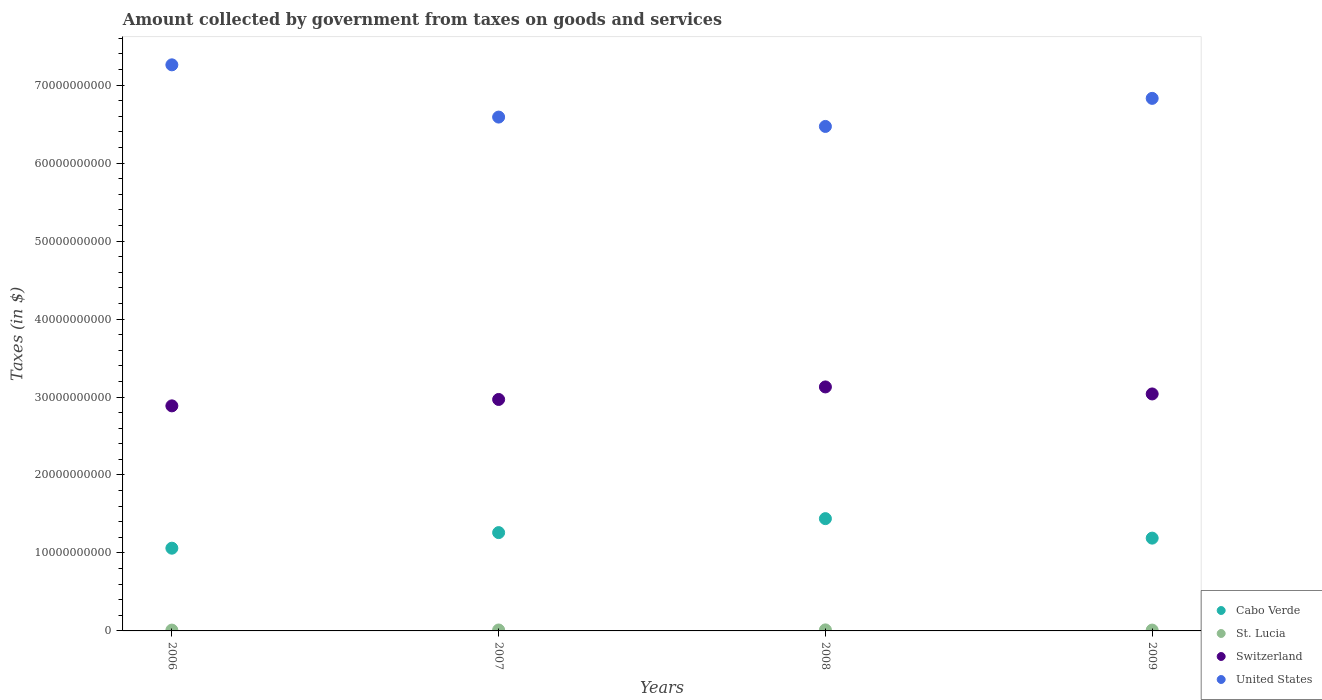How many different coloured dotlines are there?
Your answer should be compact. 4. What is the amount collected by government from taxes on goods and services in United States in 2006?
Your answer should be very brief. 7.26e+1. Across all years, what is the maximum amount collected by government from taxes on goods and services in United States?
Make the answer very short. 7.26e+1. Across all years, what is the minimum amount collected by government from taxes on goods and services in United States?
Offer a terse response. 6.47e+1. In which year was the amount collected by government from taxes on goods and services in Cabo Verde maximum?
Your response must be concise. 2008. What is the total amount collected by government from taxes on goods and services in St. Lucia in the graph?
Give a very brief answer. 4.65e+08. What is the difference between the amount collected by government from taxes on goods and services in Cabo Verde in 2006 and that in 2009?
Provide a short and direct response. -1.29e+09. What is the difference between the amount collected by government from taxes on goods and services in United States in 2006 and the amount collected by government from taxes on goods and services in Switzerland in 2009?
Offer a terse response. 4.22e+1. What is the average amount collected by government from taxes on goods and services in Switzerland per year?
Ensure brevity in your answer.  3.01e+1. In the year 2008, what is the difference between the amount collected by government from taxes on goods and services in United States and amount collected by government from taxes on goods and services in Cabo Verde?
Give a very brief answer. 5.03e+1. In how many years, is the amount collected by government from taxes on goods and services in Switzerland greater than 62000000000 $?
Provide a short and direct response. 0. What is the ratio of the amount collected by government from taxes on goods and services in Switzerland in 2008 to that in 2009?
Your answer should be very brief. 1.03. Is the amount collected by government from taxes on goods and services in United States in 2006 less than that in 2008?
Provide a succinct answer. No. What is the difference between the highest and the second highest amount collected by government from taxes on goods and services in Cabo Verde?
Offer a very short reply. 1.79e+09. What is the difference between the highest and the lowest amount collected by government from taxes on goods and services in United States?
Offer a very short reply. 7.90e+09. Is the sum of the amount collected by government from taxes on goods and services in United States in 2006 and 2009 greater than the maximum amount collected by government from taxes on goods and services in Cabo Verde across all years?
Your answer should be very brief. Yes. Is it the case that in every year, the sum of the amount collected by government from taxes on goods and services in Cabo Verde and amount collected by government from taxes on goods and services in United States  is greater than the sum of amount collected by government from taxes on goods and services in St. Lucia and amount collected by government from taxes on goods and services in Switzerland?
Offer a very short reply. Yes. Is it the case that in every year, the sum of the amount collected by government from taxes on goods and services in Cabo Verde and amount collected by government from taxes on goods and services in United States  is greater than the amount collected by government from taxes on goods and services in Switzerland?
Make the answer very short. Yes. Does the amount collected by government from taxes on goods and services in Switzerland monotonically increase over the years?
Provide a succinct answer. No. Is the amount collected by government from taxes on goods and services in Switzerland strictly greater than the amount collected by government from taxes on goods and services in United States over the years?
Make the answer very short. No. How many dotlines are there?
Offer a terse response. 4. How many years are there in the graph?
Keep it short and to the point. 4. What is the difference between two consecutive major ticks on the Y-axis?
Your response must be concise. 1.00e+1. Are the values on the major ticks of Y-axis written in scientific E-notation?
Provide a succinct answer. No. Where does the legend appear in the graph?
Provide a succinct answer. Bottom right. How are the legend labels stacked?
Offer a terse response. Vertical. What is the title of the graph?
Ensure brevity in your answer.  Amount collected by government from taxes on goods and services. Does "French Polynesia" appear as one of the legend labels in the graph?
Your response must be concise. No. What is the label or title of the Y-axis?
Offer a terse response. Taxes (in $). What is the Taxes (in $) in Cabo Verde in 2006?
Offer a terse response. 1.06e+1. What is the Taxes (in $) in St. Lucia in 2006?
Make the answer very short. 1.06e+08. What is the Taxes (in $) of Switzerland in 2006?
Your response must be concise. 2.89e+1. What is the Taxes (in $) of United States in 2006?
Give a very brief answer. 7.26e+1. What is the Taxes (in $) in Cabo Verde in 2007?
Ensure brevity in your answer.  1.26e+1. What is the Taxes (in $) of St. Lucia in 2007?
Provide a succinct answer. 1.20e+08. What is the Taxes (in $) in Switzerland in 2007?
Your answer should be very brief. 2.97e+1. What is the Taxes (in $) in United States in 2007?
Ensure brevity in your answer.  6.59e+1. What is the Taxes (in $) in Cabo Verde in 2008?
Make the answer very short. 1.44e+1. What is the Taxes (in $) of St. Lucia in 2008?
Offer a very short reply. 1.32e+08. What is the Taxes (in $) in Switzerland in 2008?
Make the answer very short. 3.13e+1. What is the Taxes (in $) in United States in 2008?
Make the answer very short. 6.47e+1. What is the Taxes (in $) in Cabo Verde in 2009?
Keep it short and to the point. 1.19e+1. What is the Taxes (in $) in St. Lucia in 2009?
Make the answer very short. 1.07e+08. What is the Taxes (in $) in Switzerland in 2009?
Your answer should be compact. 3.04e+1. What is the Taxes (in $) in United States in 2009?
Provide a succinct answer. 6.83e+1. Across all years, what is the maximum Taxes (in $) of Cabo Verde?
Provide a short and direct response. 1.44e+1. Across all years, what is the maximum Taxes (in $) in St. Lucia?
Make the answer very short. 1.32e+08. Across all years, what is the maximum Taxes (in $) in Switzerland?
Your response must be concise. 3.13e+1. Across all years, what is the maximum Taxes (in $) in United States?
Offer a very short reply. 7.26e+1. Across all years, what is the minimum Taxes (in $) in Cabo Verde?
Offer a terse response. 1.06e+1. Across all years, what is the minimum Taxes (in $) of St. Lucia?
Your answer should be compact. 1.06e+08. Across all years, what is the minimum Taxes (in $) in Switzerland?
Provide a short and direct response. 2.89e+1. Across all years, what is the minimum Taxes (in $) in United States?
Give a very brief answer. 6.47e+1. What is the total Taxes (in $) of Cabo Verde in the graph?
Provide a succinct answer. 4.95e+1. What is the total Taxes (in $) of St. Lucia in the graph?
Ensure brevity in your answer.  4.65e+08. What is the total Taxes (in $) in Switzerland in the graph?
Make the answer very short. 1.20e+11. What is the total Taxes (in $) in United States in the graph?
Your answer should be compact. 2.72e+11. What is the difference between the Taxes (in $) of Cabo Verde in 2006 and that in 2007?
Make the answer very short. -2.00e+09. What is the difference between the Taxes (in $) of St. Lucia in 2006 and that in 2007?
Offer a very short reply. -1.41e+07. What is the difference between the Taxes (in $) of Switzerland in 2006 and that in 2007?
Give a very brief answer. -8.22e+08. What is the difference between the Taxes (in $) of United States in 2006 and that in 2007?
Make the answer very short. 6.70e+09. What is the difference between the Taxes (in $) in Cabo Verde in 2006 and that in 2008?
Make the answer very short. -3.79e+09. What is the difference between the Taxes (in $) in St. Lucia in 2006 and that in 2008?
Provide a succinct answer. -2.66e+07. What is the difference between the Taxes (in $) in Switzerland in 2006 and that in 2008?
Provide a short and direct response. -2.43e+09. What is the difference between the Taxes (in $) in United States in 2006 and that in 2008?
Make the answer very short. 7.90e+09. What is the difference between the Taxes (in $) of Cabo Verde in 2006 and that in 2009?
Provide a short and direct response. -1.29e+09. What is the difference between the Taxes (in $) of St. Lucia in 2006 and that in 2009?
Offer a very short reply. -1.80e+06. What is the difference between the Taxes (in $) of Switzerland in 2006 and that in 2009?
Give a very brief answer. -1.53e+09. What is the difference between the Taxes (in $) in United States in 2006 and that in 2009?
Your answer should be very brief. 4.30e+09. What is the difference between the Taxes (in $) in Cabo Verde in 2007 and that in 2008?
Make the answer very short. -1.79e+09. What is the difference between the Taxes (in $) in St. Lucia in 2007 and that in 2008?
Keep it short and to the point. -1.25e+07. What is the difference between the Taxes (in $) of Switzerland in 2007 and that in 2008?
Offer a very short reply. -1.61e+09. What is the difference between the Taxes (in $) in United States in 2007 and that in 2008?
Offer a very short reply. 1.20e+09. What is the difference between the Taxes (in $) in Cabo Verde in 2007 and that in 2009?
Your response must be concise. 7.08e+08. What is the difference between the Taxes (in $) in St. Lucia in 2007 and that in 2009?
Keep it short and to the point. 1.23e+07. What is the difference between the Taxes (in $) of Switzerland in 2007 and that in 2009?
Make the answer very short. -7.08e+08. What is the difference between the Taxes (in $) in United States in 2007 and that in 2009?
Make the answer very short. -2.40e+09. What is the difference between the Taxes (in $) in Cabo Verde in 2008 and that in 2009?
Provide a succinct answer. 2.50e+09. What is the difference between the Taxes (in $) in St. Lucia in 2008 and that in 2009?
Your answer should be very brief. 2.48e+07. What is the difference between the Taxes (in $) in Switzerland in 2008 and that in 2009?
Your answer should be very brief. 9.00e+08. What is the difference between the Taxes (in $) in United States in 2008 and that in 2009?
Your response must be concise. -3.60e+09. What is the difference between the Taxes (in $) in Cabo Verde in 2006 and the Taxes (in $) in St. Lucia in 2007?
Provide a succinct answer. 1.05e+1. What is the difference between the Taxes (in $) in Cabo Verde in 2006 and the Taxes (in $) in Switzerland in 2007?
Offer a terse response. -1.91e+1. What is the difference between the Taxes (in $) in Cabo Verde in 2006 and the Taxes (in $) in United States in 2007?
Your response must be concise. -5.53e+1. What is the difference between the Taxes (in $) of St. Lucia in 2006 and the Taxes (in $) of Switzerland in 2007?
Make the answer very short. -2.96e+1. What is the difference between the Taxes (in $) of St. Lucia in 2006 and the Taxes (in $) of United States in 2007?
Provide a succinct answer. -6.58e+1. What is the difference between the Taxes (in $) in Switzerland in 2006 and the Taxes (in $) in United States in 2007?
Make the answer very short. -3.70e+1. What is the difference between the Taxes (in $) in Cabo Verde in 2006 and the Taxes (in $) in St. Lucia in 2008?
Ensure brevity in your answer.  1.05e+1. What is the difference between the Taxes (in $) in Cabo Verde in 2006 and the Taxes (in $) in Switzerland in 2008?
Your response must be concise. -2.07e+1. What is the difference between the Taxes (in $) in Cabo Verde in 2006 and the Taxes (in $) in United States in 2008?
Keep it short and to the point. -5.41e+1. What is the difference between the Taxes (in $) in St. Lucia in 2006 and the Taxes (in $) in Switzerland in 2008?
Keep it short and to the point. -3.12e+1. What is the difference between the Taxes (in $) in St. Lucia in 2006 and the Taxes (in $) in United States in 2008?
Provide a short and direct response. -6.46e+1. What is the difference between the Taxes (in $) in Switzerland in 2006 and the Taxes (in $) in United States in 2008?
Your response must be concise. -3.58e+1. What is the difference between the Taxes (in $) of Cabo Verde in 2006 and the Taxes (in $) of St. Lucia in 2009?
Your response must be concise. 1.05e+1. What is the difference between the Taxes (in $) in Cabo Verde in 2006 and the Taxes (in $) in Switzerland in 2009?
Keep it short and to the point. -1.98e+1. What is the difference between the Taxes (in $) in Cabo Verde in 2006 and the Taxes (in $) in United States in 2009?
Your response must be concise. -5.77e+1. What is the difference between the Taxes (in $) of St. Lucia in 2006 and the Taxes (in $) of Switzerland in 2009?
Offer a very short reply. -3.03e+1. What is the difference between the Taxes (in $) of St. Lucia in 2006 and the Taxes (in $) of United States in 2009?
Provide a short and direct response. -6.82e+1. What is the difference between the Taxes (in $) in Switzerland in 2006 and the Taxes (in $) in United States in 2009?
Provide a short and direct response. -3.94e+1. What is the difference between the Taxes (in $) of Cabo Verde in 2007 and the Taxes (in $) of St. Lucia in 2008?
Provide a succinct answer. 1.25e+1. What is the difference between the Taxes (in $) in Cabo Verde in 2007 and the Taxes (in $) in Switzerland in 2008?
Offer a terse response. -1.87e+1. What is the difference between the Taxes (in $) of Cabo Verde in 2007 and the Taxes (in $) of United States in 2008?
Give a very brief answer. -5.21e+1. What is the difference between the Taxes (in $) of St. Lucia in 2007 and the Taxes (in $) of Switzerland in 2008?
Provide a succinct answer. -3.12e+1. What is the difference between the Taxes (in $) in St. Lucia in 2007 and the Taxes (in $) in United States in 2008?
Keep it short and to the point. -6.46e+1. What is the difference between the Taxes (in $) in Switzerland in 2007 and the Taxes (in $) in United States in 2008?
Your answer should be compact. -3.50e+1. What is the difference between the Taxes (in $) in Cabo Verde in 2007 and the Taxes (in $) in St. Lucia in 2009?
Ensure brevity in your answer.  1.25e+1. What is the difference between the Taxes (in $) in Cabo Verde in 2007 and the Taxes (in $) in Switzerland in 2009?
Keep it short and to the point. -1.78e+1. What is the difference between the Taxes (in $) of Cabo Verde in 2007 and the Taxes (in $) of United States in 2009?
Offer a very short reply. -5.57e+1. What is the difference between the Taxes (in $) in St. Lucia in 2007 and the Taxes (in $) in Switzerland in 2009?
Keep it short and to the point. -3.03e+1. What is the difference between the Taxes (in $) in St. Lucia in 2007 and the Taxes (in $) in United States in 2009?
Keep it short and to the point. -6.82e+1. What is the difference between the Taxes (in $) of Switzerland in 2007 and the Taxes (in $) of United States in 2009?
Your answer should be compact. -3.86e+1. What is the difference between the Taxes (in $) in Cabo Verde in 2008 and the Taxes (in $) in St. Lucia in 2009?
Offer a terse response. 1.43e+1. What is the difference between the Taxes (in $) in Cabo Verde in 2008 and the Taxes (in $) in Switzerland in 2009?
Provide a succinct answer. -1.60e+1. What is the difference between the Taxes (in $) in Cabo Verde in 2008 and the Taxes (in $) in United States in 2009?
Your answer should be compact. -5.39e+1. What is the difference between the Taxes (in $) in St. Lucia in 2008 and the Taxes (in $) in Switzerland in 2009?
Provide a short and direct response. -3.03e+1. What is the difference between the Taxes (in $) in St. Lucia in 2008 and the Taxes (in $) in United States in 2009?
Provide a short and direct response. -6.82e+1. What is the difference between the Taxes (in $) in Switzerland in 2008 and the Taxes (in $) in United States in 2009?
Offer a very short reply. -3.70e+1. What is the average Taxes (in $) in Cabo Verde per year?
Your answer should be very brief. 1.24e+1. What is the average Taxes (in $) in St. Lucia per year?
Give a very brief answer. 1.16e+08. What is the average Taxes (in $) of Switzerland per year?
Provide a short and direct response. 3.01e+1. What is the average Taxes (in $) of United States per year?
Provide a short and direct response. 6.79e+1. In the year 2006, what is the difference between the Taxes (in $) of Cabo Verde and Taxes (in $) of St. Lucia?
Your answer should be very brief. 1.05e+1. In the year 2006, what is the difference between the Taxes (in $) of Cabo Verde and Taxes (in $) of Switzerland?
Your answer should be compact. -1.83e+1. In the year 2006, what is the difference between the Taxes (in $) in Cabo Verde and Taxes (in $) in United States?
Make the answer very short. -6.20e+1. In the year 2006, what is the difference between the Taxes (in $) in St. Lucia and Taxes (in $) in Switzerland?
Keep it short and to the point. -2.88e+1. In the year 2006, what is the difference between the Taxes (in $) in St. Lucia and Taxes (in $) in United States?
Make the answer very short. -7.25e+1. In the year 2006, what is the difference between the Taxes (in $) of Switzerland and Taxes (in $) of United States?
Your answer should be very brief. -4.37e+1. In the year 2007, what is the difference between the Taxes (in $) of Cabo Verde and Taxes (in $) of St. Lucia?
Keep it short and to the point. 1.25e+1. In the year 2007, what is the difference between the Taxes (in $) in Cabo Verde and Taxes (in $) in Switzerland?
Your answer should be very brief. -1.71e+1. In the year 2007, what is the difference between the Taxes (in $) in Cabo Verde and Taxes (in $) in United States?
Offer a terse response. -5.33e+1. In the year 2007, what is the difference between the Taxes (in $) of St. Lucia and Taxes (in $) of Switzerland?
Ensure brevity in your answer.  -2.96e+1. In the year 2007, what is the difference between the Taxes (in $) of St. Lucia and Taxes (in $) of United States?
Ensure brevity in your answer.  -6.58e+1. In the year 2007, what is the difference between the Taxes (in $) of Switzerland and Taxes (in $) of United States?
Ensure brevity in your answer.  -3.62e+1. In the year 2008, what is the difference between the Taxes (in $) of Cabo Verde and Taxes (in $) of St. Lucia?
Provide a short and direct response. 1.43e+1. In the year 2008, what is the difference between the Taxes (in $) of Cabo Verde and Taxes (in $) of Switzerland?
Offer a very short reply. -1.69e+1. In the year 2008, what is the difference between the Taxes (in $) in Cabo Verde and Taxes (in $) in United States?
Provide a short and direct response. -5.03e+1. In the year 2008, what is the difference between the Taxes (in $) in St. Lucia and Taxes (in $) in Switzerland?
Provide a succinct answer. -3.12e+1. In the year 2008, what is the difference between the Taxes (in $) of St. Lucia and Taxes (in $) of United States?
Ensure brevity in your answer.  -6.46e+1. In the year 2008, what is the difference between the Taxes (in $) of Switzerland and Taxes (in $) of United States?
Provide a succinct answer. -3.34e+1. In the year 2009, what is the difference between the Taxes (in $) of Cabo Verde and Taxes (in $) of St. Lucia?
Provide a succinct answer. 1.18e+1. In the year 2009, what is the difference between the Taxes (in $) of Cabo Verde and Taxes (in $) of Switzerland?
Provide a succinct answer. -1.85e+1. In the year 2009, what is the difference between the Taxes (in $) in Cabo Verde and Taxes (in $) in United States?
Keep it short and to the point. -5.64e+1. In the year 2009, what is the difference between the Taxes (in $) in St. Lucia and Taxes (in $) in Switzerland?
Offer a very short reply. -3.03e+1. In the year 2009, what is the difference between the Taxes (in $) in St. Lucia and Taxes (in $) in United States?
Make the answer very short. -6.82e+1. In the year 2009, what is the difference between the Taxes (in $) of Switzerland and Taxes (in $) of United States?
Offer a terse response. -3.79e+1. What is the ratio of the Taxes (in $) in Cabo Verde in 2006 to that in 2007?
Make the answer very short. 0.84. What is the ratio of the Taxes (in $) of St. Lucia in 2006 to that in 2007?
Your answer should be compact. 0.88. What is the ratio of the Taxes (in $) in Switzerland in 2006 to that in 2007?
Give a very brief answer. 0.97. What is the ratio of the Taxes (in $) in United States in 2006 to that in 2007?
Your response must be concise. 1.1. What is the ratio of the Taxes (in $) in Cabo Verde in 2006 to that in 2008?
Your response must be concise. 0.74. What is the ratio of the Taxes (in $) of St. Lucia in 2006 to that in 2008?
Offer a very short reply. 0.8. What is the ratio of the Taxes (in $) of Switzerland in 2006 to that in 2008?
Your answer should be compact. 0.92. What is the ratio of the Taxes (in $) of United States in 2006 to that in 2008?
Keep it short and to the point. 1.12. What is the ratio of the Taxes (in $) of Cabo Verde in 2006 to that in 2009?
Keep it short and to the point. 0.89. What is the ratio of the Taxes (in $) of St. Lucia in 2006 to that in 2009?
Your answer should be very brief. 0.98. What is the ratio of the Taxes (in $) in Switzerland in 2006 to that in 2009?
Ensure brevity in your answer.  0.95. What is the ratio of the Taxes (in $) in United States in 2006 to that in 2009?
Offer a very short reply. 1.06. What is the ratio of the Taxes (in $) of Cabo Verde in 2007 to that in 2008?
Ensure brevity in your answer.  0.88. What is the ratio of the Taxes (in $) in St. Lucia in 2007 to that in 2008?
Offer a very short reply. 0.91. What is the ratio of the Taxes (in $) in Switzerland in 2007 to that in 2008?
Offer a terse response. 0.95. What is the ratio of the Taxes (in $) of United States in 2007 to that in 2008?
Give a very brief answer. 1.02. What is the ratio of the Taxes (in $) of Cabo Verde in 2007 to that in 2009?
Your response must be concise. 1.06. What is the ratio of the Taxes (in $) of St. Lucia in 2007 to that in 2009?
Offer a terse response. 1.11. What is the ratio of the Taxes (in $) of Switzerland in 2007 to that in 2009?
Keep it short and to the point. 0.98. What is the ratio of the Taxes (in $) of United States in 2007 to that in 2009?
Provide a succinct answer. 0.96. What is the ratio of the Taxes (in $) of Cabo Verde in 2008 to that in 2009?
Make the answer very short. 1.21. What is the ratio of the Taxes (in $) of St. Lucia in 2008 to that in 2009?
Offer a terse response. 1.23. What is the ratio of the Taxes (in $) of Switzerland in 2008 to that in 2009?
Offer a terse response. 1.03. What is the ratio of the Taxes (in $) of United States in 2008 to that in 2009?
Make the answer very short. 0.95. What is the difference between the highest and the second highest Taxes (in $) of Cabo Verde?
Keep it short and to the point. 1.79e+09. What is the difference between the highest and the second highest Taxes (in $) in St. Lucia?
Your response must be concise. 1.25e+07. What is the difference between the highest and the second highest Taxes (in $) in Switzerland?
Keep it short and to the point. 9.00e+08. What is the difference between the highest and the second highest Taxes (in $) of United States?
Give a very brief answer. 4.30e+09. What is the difference between the highest and the lowest Taxes (in $) of Cabo Verde?
Your answer should be very brief. 3.79e+09. What is the difference between the highest and the lowest Taxes (in $) of St. Lucia?
Offer a terse response. 2.66e+07. What is the difference between the highest and the lowest Taxes (in $) in Switzerland?
Your response must be concise. 2.43e+09. What is the difference between the highest and the lowest Taxes (in $) of United States?
Ensure brevity in your answer.  7.90e+09. 